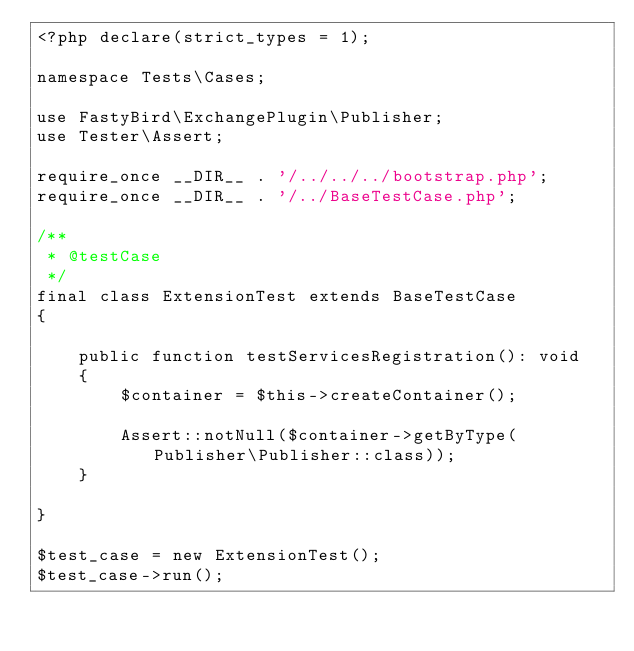Convert code to text. <code><loc_0><loc_0><loc_500><loc_500><_PHP_><?php declare(strict_types = 1);

namespace Tests\Cases;

use FastyBird\ExchangePlugin\Publisher;
use Tester\Assert;

require_once __DIR__ . '/../../../bootstrap.php';
require_once __DIR__ . '/../BaseTestCase.php';

/**
 * @testCase
 */
final class ExtensionTest extends BaseTestCase
{

	public function testServicesRegistration(): void
	{
		$container = $this->createContainer();

		Assert::notNull($container->getByType(Publisher\Publisher::class));
	}

}

$test_case = new ExtensionTest();
$test_case->run();
</code> 